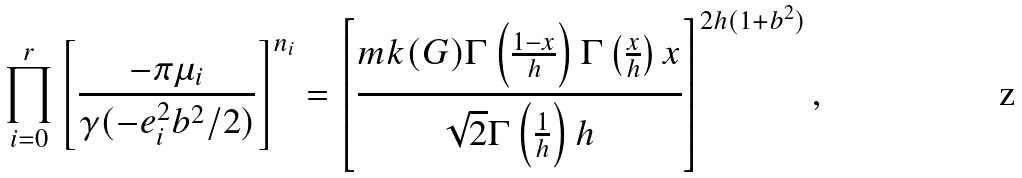Convert formula to latex. <formula><loc_0><loc_0><loc_500><loc_500>\prod _ { i = 0 } ^ { r } \left [ \frac { - \pi \mu _ { i } } { \gamma ( - e _ { i } ^ { 2 } b ^ { 2 } / 2 ) } \right ] ^ { n _ { i } } = \left [ \frac { m k ( G ) \Gamma \left ( \frac { 1 - x } { h } \right ) \Gamma \left ( \frac { x } { h } \right ) x } { \sqrt { 2 } \Gamma \left ( \frac { 1 } { h } \right ) h } \right ] ^ { 2 h ( 1 + b ^ { 2 } ) } ,</formula> 